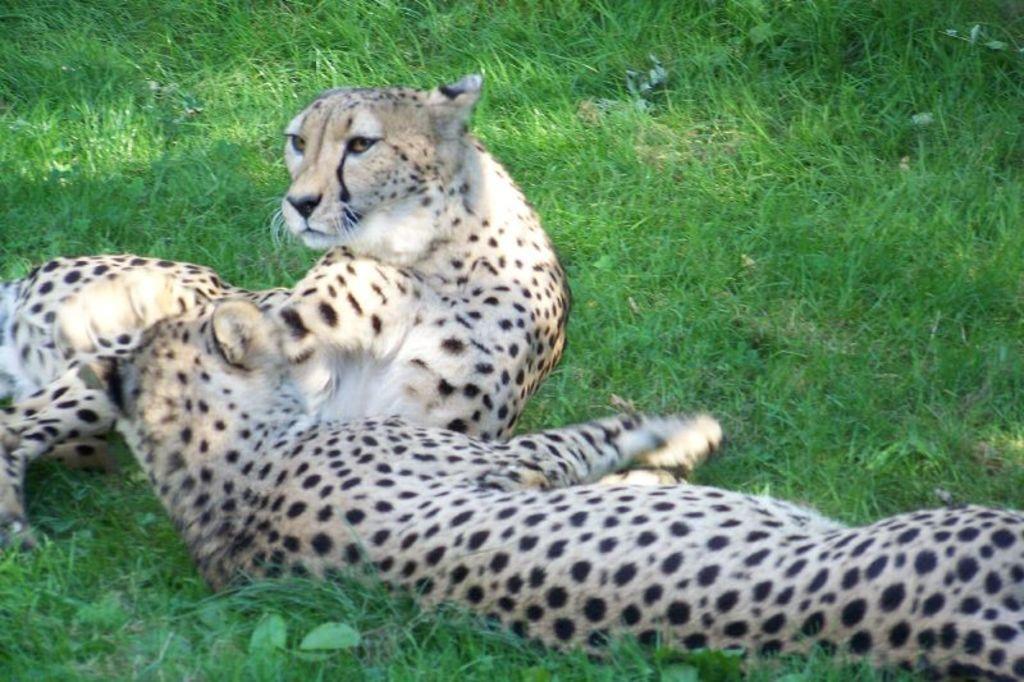Could you give a brief overview of what you see in this image? In this image there are two leopards on the grass. 